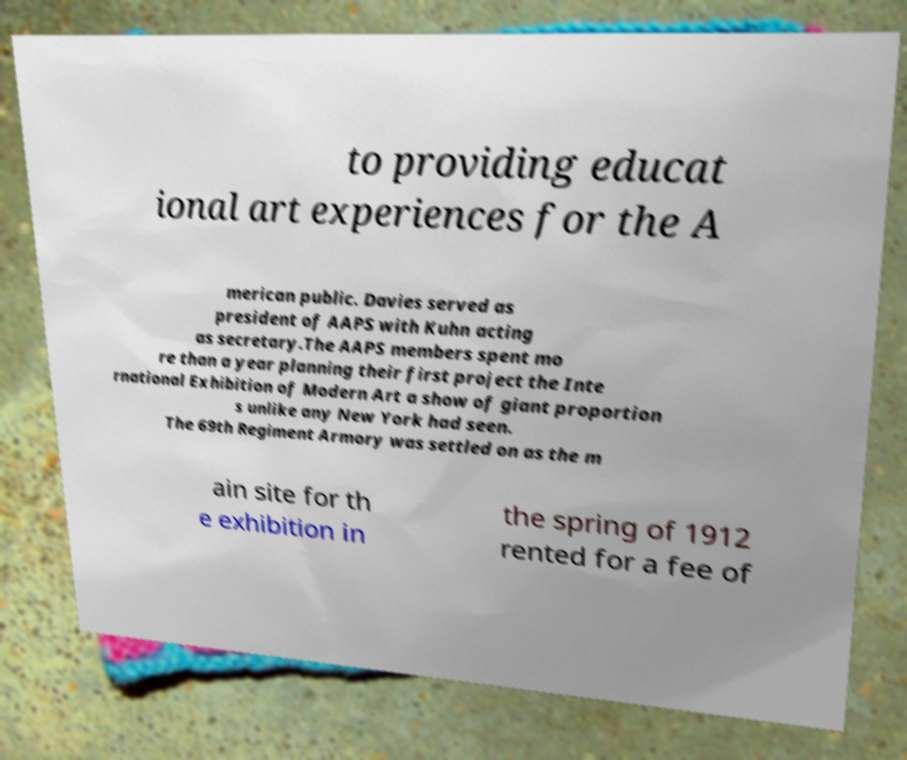Please read and relay the text visible in this image. What does it say? to providing educat ional art experiences for the A merican public. Davies served as president of AAPS with Kuhn acting as secretary.The AAPS members spent mo re than a year planning their first project the Inte rnational Exhibition of Modern Art a show of giant proportion s unlike any New York had seen. The 69th Regiment Armory was settled on as the m ain site for th e exhibition in the spring of 1912 rented for a fee of 